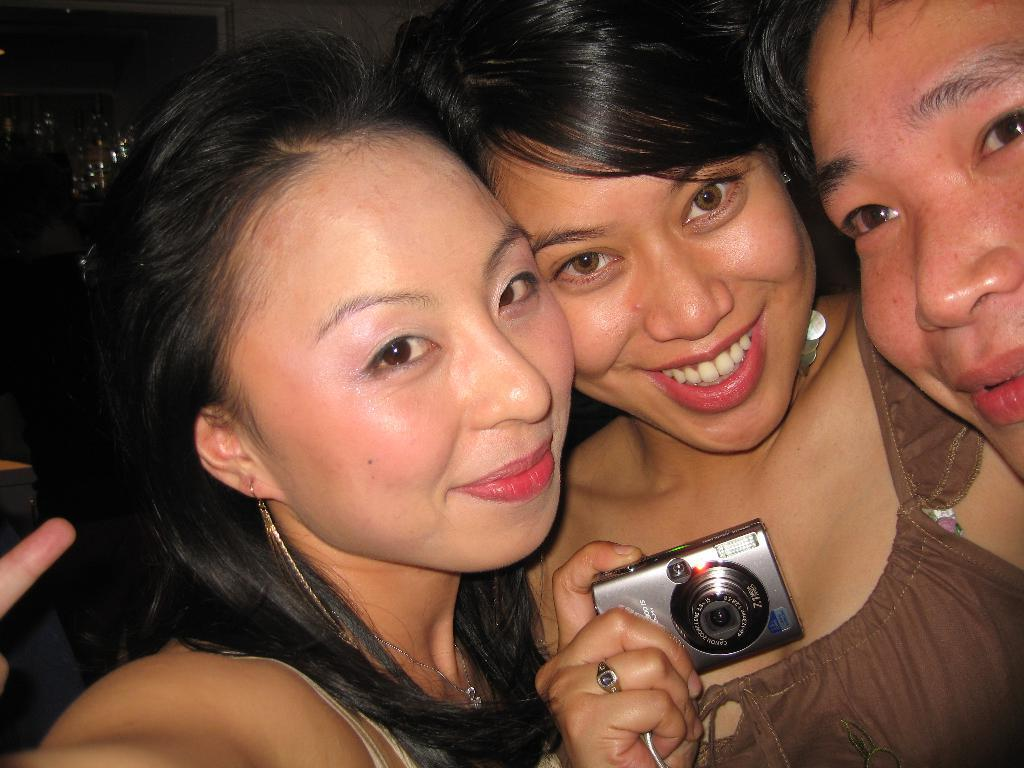Who is present in the image? There are people in the image. What are the people doing in the image? The people are smiling. Can you describe the woman in the image? The woman is holding a camera. What type of weather can be seen in the picture? There is no picture present in the image, and therefore no weather can be observed. 